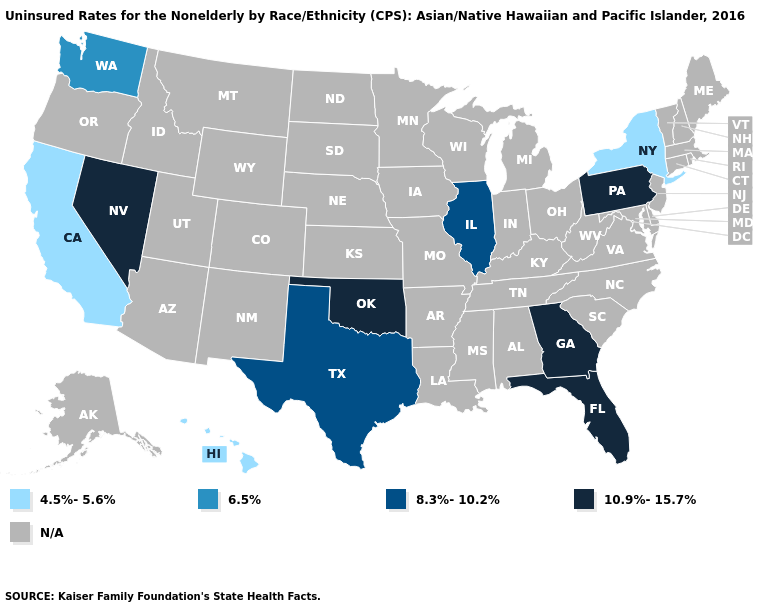Name the states that have a value in the range N/A?
Write a very short answer. Alabama, Alaska, Arizona, Arkansas, Colorado, Connecticut, Delaware, Idaho, Indiana, Iowa, Kansas, Kentucky, Louisiana, Maine, Maryland, Massachusetts, Michigan, Minnesota, Mississippi, Missouri, Montana, Nebraska, New Hampshire, New Jersey, New Mexico, North Carolina, North Dakota, Ohio, Oregon, Rhode Island, South Carolina, South Dakota, Tennessee, Utah, Vermont, Virginia, West Virginia, Wisconsin, Wyoming. What is the value of Tennessee?
Answer briefly. N/A. Which states hav the highest value in the South?
Give a very brief answer. Florida, Georgia, Oklahoma. Does Texas have the highest value in the USA?
Short answer required. No. Which states hav the highest value in the South?
Give a very brief answer. Florida, Georgia, Oklahoma. Which states hav the highest value in the West?
Keep it brief. Nevada. Which states have the highest value in the USA?
Answer briefly. Florida, Georgia, Nevada, Oklahoma, Pennsylvania. Among the states that border Kentucky , which have the lowest value?
Quick response, please. Illinois. Name the states that have a value in the range 10.9%-15.7%?
Write a very short answer. Florida, Georgia, Nevada, Oklahoma, Pennsylvania. Does Texas have the highest value in the USA?
Quick response, please. No. Name the states that have a value in the range N/A?
Give a very brief answer. Alabama, Alaska, Arizona, Arkansas, Colorado, Connecticut, Delaware, Idaho, Indiana, Iowa, Kansas, Kentucky, Louisiana, Maine, Maryland, Massachusetts, Michigan, Minnesota, Mississippi, Missouri, Montana, Nebraska, New Hampshire, New Jersey, New Mexico, North Carolina, North Dakota, Ohio, Oregon, Rhode Island, South Carolina, South Dakota, Tennessee, Utah, Vermont, Virginia, West Virginia, Wisconsin, Wyoming. Which states have the lowest value in the USA?
Give a very brief answer. California, Hawaii, New York. Which states have the lowest value in the South?
Concise answer only. Texas. What is the value of Arkansas?
Answer briefly. N/A. 